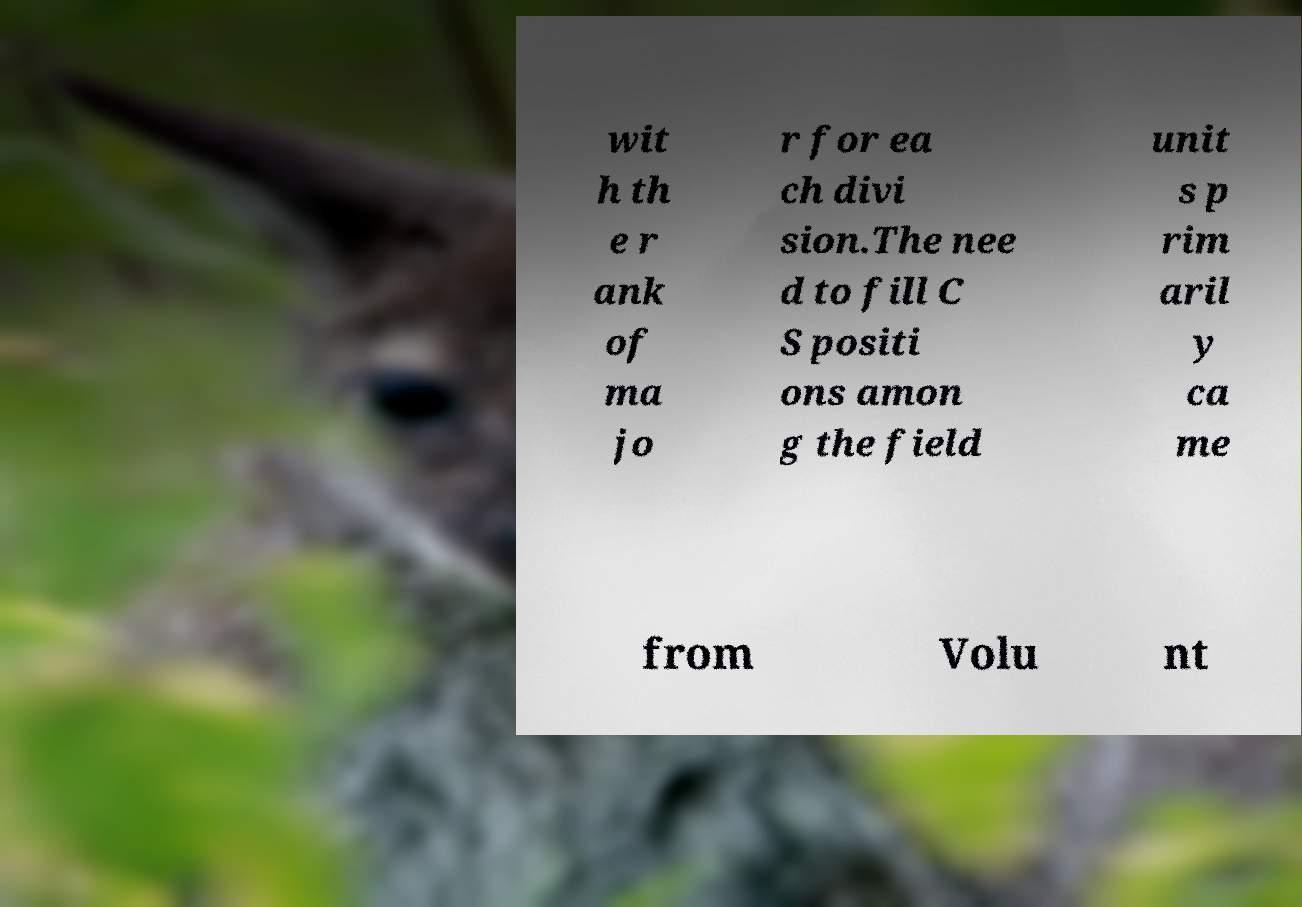Could you assist in decoding the text presented in this image and type it out clearly? wit h th e r ank of ma jo r for ea ch divi sion.The nee d to fill C S positi ons amon g the field unit s p rim aril y ca me from Volu nt 